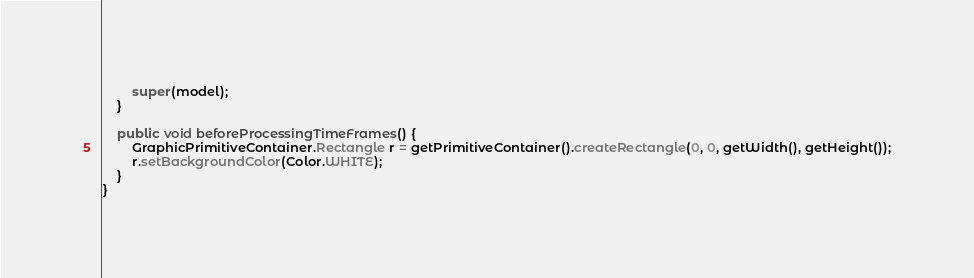<code> <loc_0><loc_0><loc_500><loc_500><_Java_>        super(model);
    }

    public void beforeProcessingTimeFrames() {
        GraphicPrimitiveContainer.Rectangle r = getPrimitiveContainer().createRectangle(0, 0, getWidth(), getHeight());
        r.setBackgroundColor(Color.WHITE);        
    }
}
</code> 